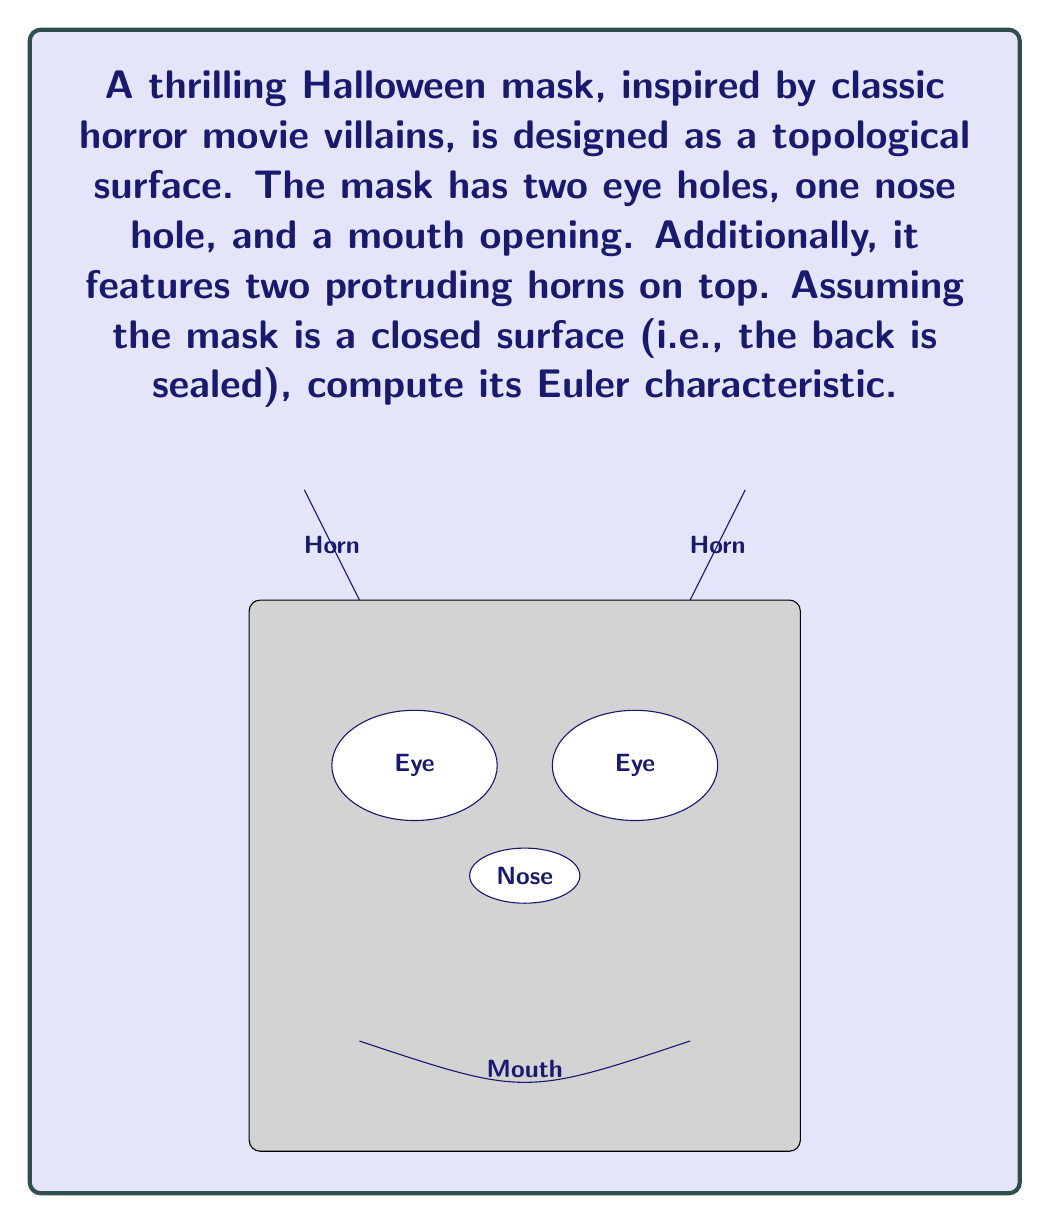What is the answer to this math problem? To compute the Euler characteristic of this Halloween mask, we'll use the formula:

$$\chi = V - E + F$$

Where:
$\chi$ is the Euler characteristic
$V$ is the number of vertices
$E$ is the number of edges
$F$ is the number of faces

Let's break down the surface:

1. Faces:
   - The main surface of the mask (1 face)
   - Two eye holes (2 faces)
   - One nose hole (1 face)
   - One mouth opening (1 face)
   - Two horns (2 faces, as they're topologically equivalent to punctures)
   Total: $F = 1 + 2 + 1 + 1 + 2 = 7$ faces

2. For a closed surface with $g$ holes (genus), the Euler characteristic is given by:
   $$\chi = 2 - 2g$$

3. Our mask has 6 holes (2 eyes + 1 nose + 1 mouth + 2 horns), so $g = 6$

4. Plugging into the formula:
   $$\chi = 2 - 2(6) = 2 - 12 = -10$$

Therefore, the Euler characteristic of the Halloween mask is -10.

Note: We didn't need to calculate $V$ and $E$ explicitly, as the genus formula for closed surfaces directly gives us the Euler characteristic.
Answer: $\chi = -10$ 